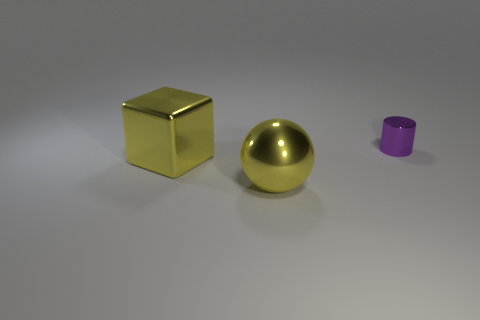Add 3 yellow objects. How many objects exist? 6 Subtract all cubes. How many objects are left? 2 Subtract 1 yellow balls. How many objects are left? 2 Subtract all big shiny cubes. Subtract all cyan shiny blocks. How many objects are left? 2 Add 2 big yellow blocks. How many big yellow blocks are left? 3 Add 1 gray spheres. How many gray spheres exist? 1 